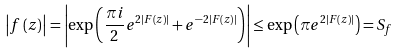Convert formula to latex. <formula><loc_0><loc_0><loc_500><loc_500>\left | f \left ( z \right ) \right | = \left | \exp \left ( \frac { \pi i } { 2 } e ^ { 2 \left | F \left ( z \right ) \right | } + e ^ { - 2 \left | F \left ( z \right ) \right | } \right ) \right | \leq \exp \left ( \pi e ^ { 2 \left | F \left ( z \right ) \right | } \right ) = S _ { f }</formula> 